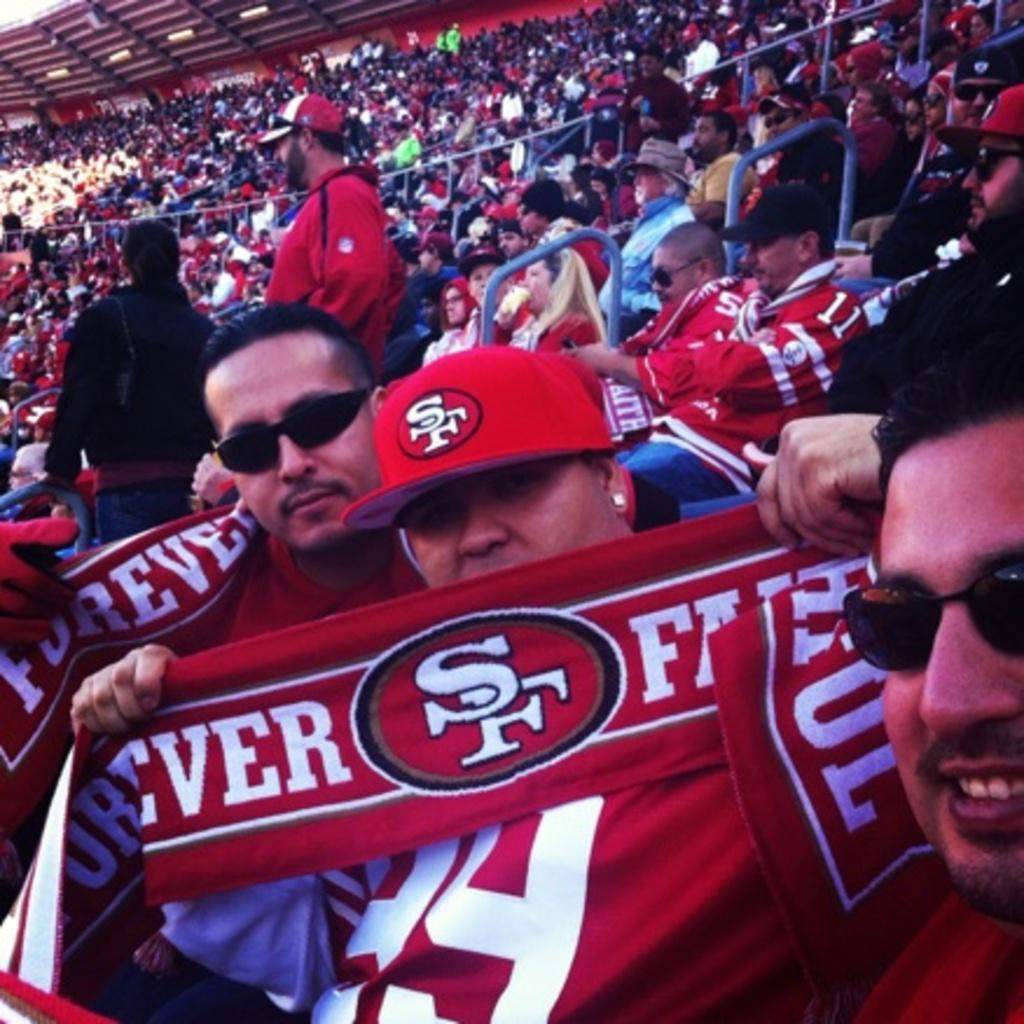Provide a one-sentence caption for the provided image. San Francisco 49ers fans holding red towels sit in the stands of the stadium. 